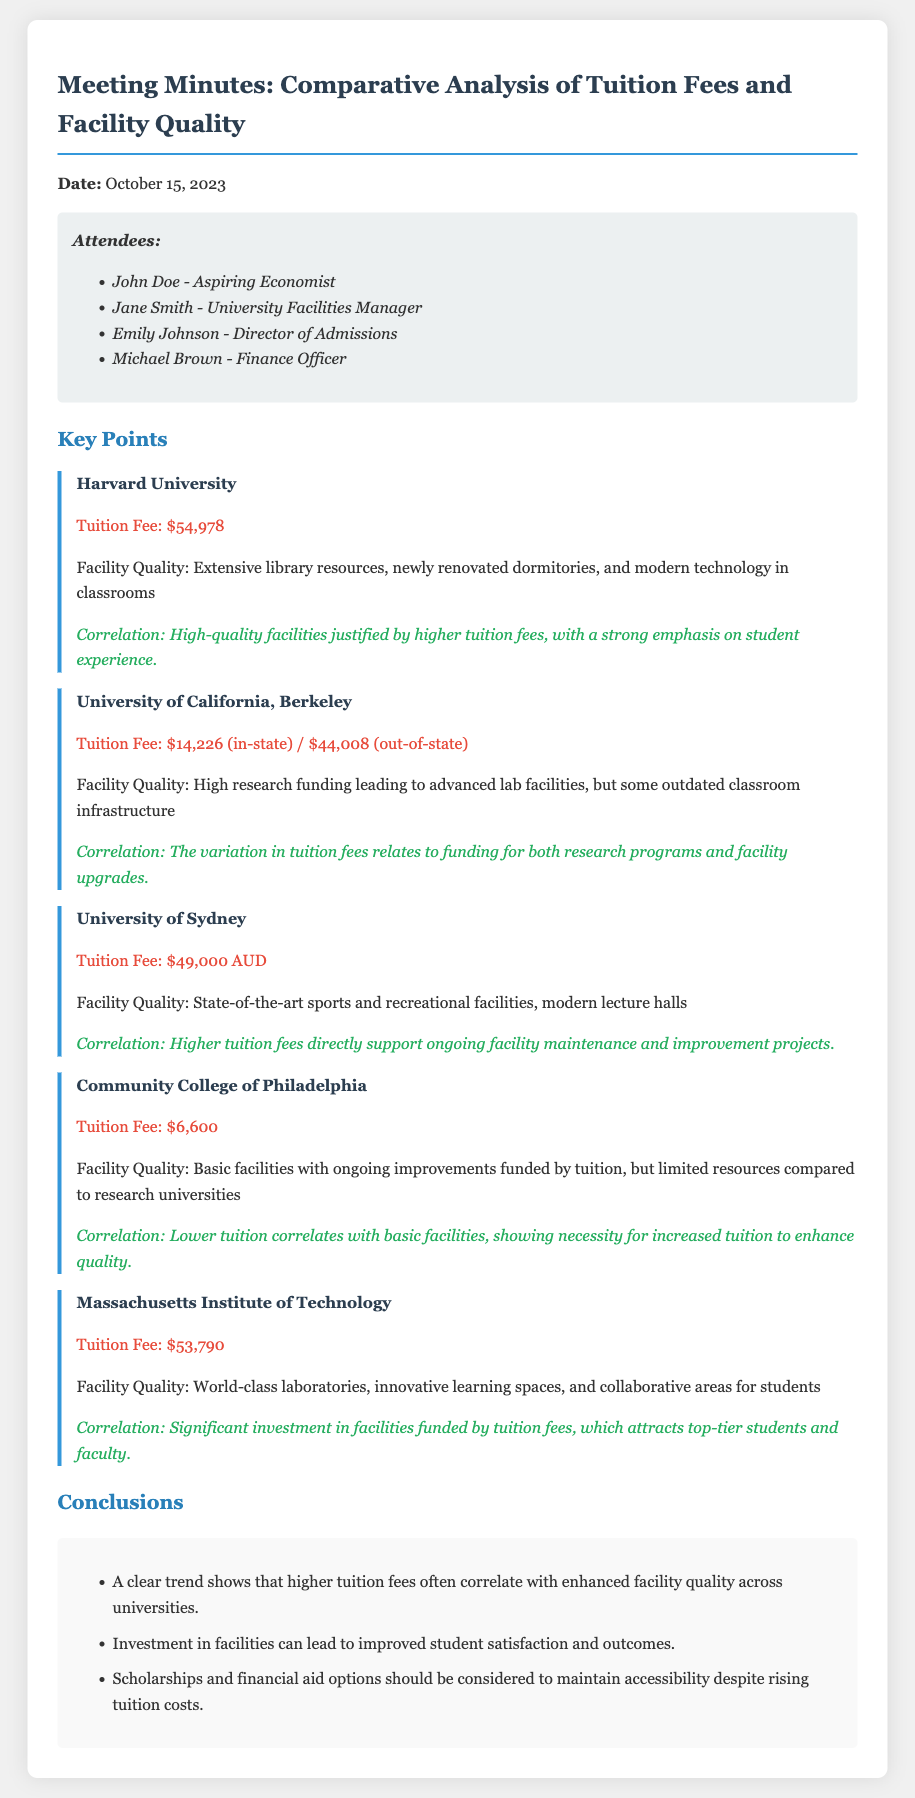What is the date of the meeting? The meeting took place on October 15, 2023, as stated at the beginning of the document.
Answer: October 15, 2023 Who is the Facilities Manager? The document lists Jane Smith as the University Facilities Manager among the attendees.
Answer: Jane Smith What is the tuition fee for Harvard University? The tuition fee for Harvard University is clearly stated in the document as $54,978.
Answer: $54,978 Which university has the lowest tuition fee? The document indicates that the Community College of Philadelphia has the lowest tuition fee mentioned at $6,600.
Answer: $6,600 What correlation is noted for the University of Sydney? The correlation described for the University of Sydney emphasizes that higher tuition fees directly support ongoing facility maintenance and improvement projects.
Answer: Higher tuition fees directly support ongoing facility maintenance and improvement projects What is a key conclusion drawn from the meeting? One of the conclusions highlights that higher tuition fees often correlate with enhanced facility quality across universities.
Answer: Higher tuition fees often correlate with enhanced facility quality What educational institution is noted for having world-class laboratories? The Massachusetts Institute of Technology is noted for having world-class laboratories in the document.
Answer: Massachusetts Institute of Technology How does the document summarize the relationship between tuition fees and facility upgrades? The document illustrates that there is a variation in tuition fees that correlates with funding for both research programs and facility upgrades at the University of California, Berkeley.
Answer: Funding for both research programs and facility upgrades 